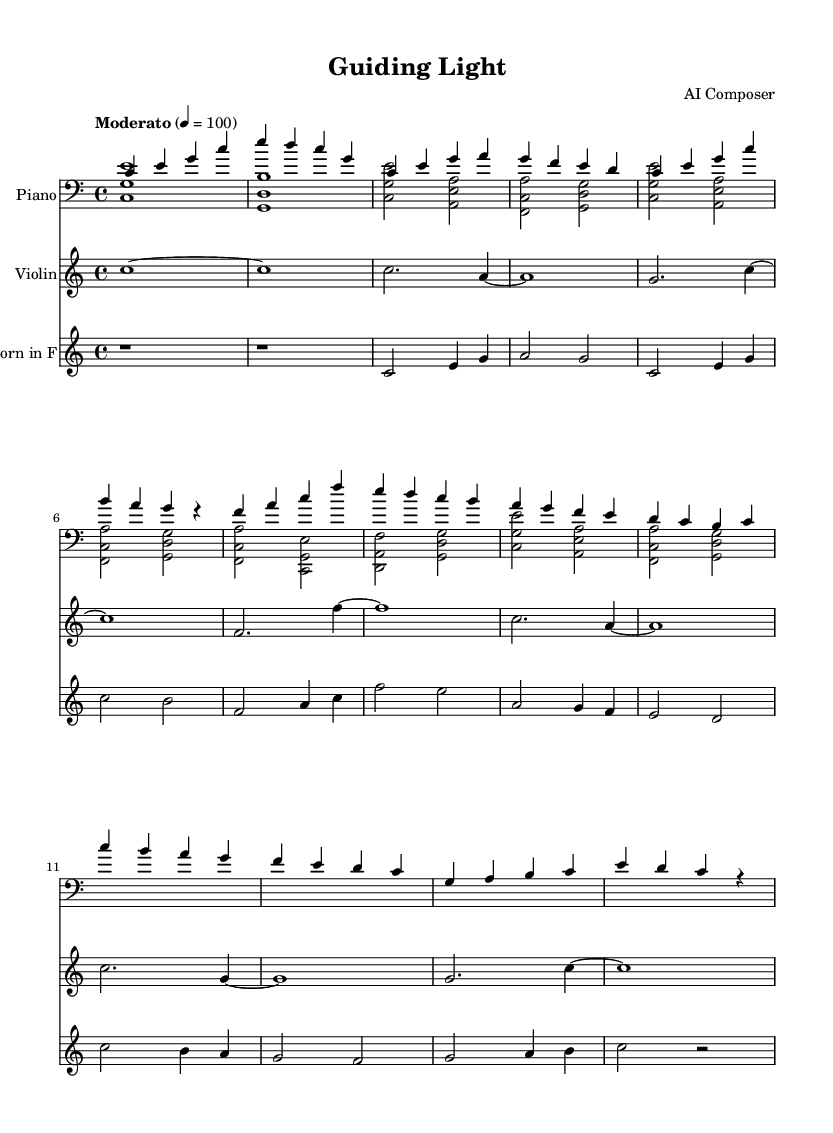What is the key signature of this music? The key signature is C major, which has no sharps or flats.
Answer: C major What is the time signature of this piece? The time signature is indicated at the beginning of the score, showing four beats per measure, which is a common signature.
Answer: 4/4 What is the tempo marking for this piece? The tempo marking suggests a moderately paced performance, and can be found written above the staff at the beginning.
Answer: Moderato Which instrument plays the melodic line in the first two measures? Analyzing the upper staff, it is clear that the Piano is playing the melodic line, while other instruments accompany it.
Answer: Piano How many instruments are featured in this score? By examining the score, we see three distinct staves, each representing a different instrument playing simultaneously.
Answer: Three What rhythmic pattern is primarily used in the left hand of the piano? Observing the left hand part of the piano staff, the pattern consists mainly of sustained notes and occasional chords, creating a harmonic foundation.
Answer: Sustained notes and chords Which instrument plays with a transposition? Looking specifically at the instrument labeled "Horn in F," it is evident that this instrument is notated a perfect fifth lower than concert pitch.
Answer: French Horn 